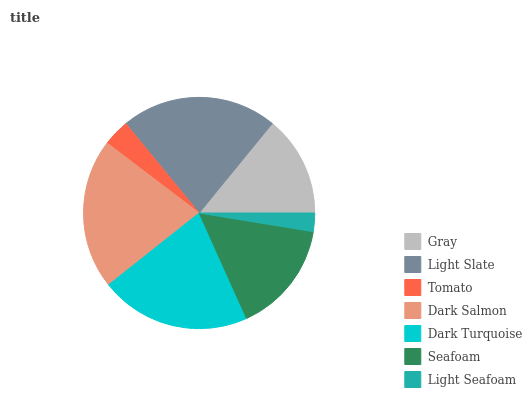Is Light Seafoam the minimum?
Answer yes or no. Yes. Is Light Slate the maximum?
Answer yes or no. Yes. Is Tomato the minimum?
Answer yes or no. No. Is Tomato the maximum?
Answer yes or no. No. Is Light Slate greater than Tomato?
Answer yes or no. Yes. Is Tomato less than Light Slate?
Answer yes or no. Yes. Is Tomato greater than Light Slate?
Answer yes or no. No. Is Light Slate less than Tomato?
Answer yes or no. No. Is Seafoam the high median?
Answer yes or no. Yes. Is Seafoam the low median?
Answer yes or no. Yes. Is Light Seafoam the high median?
Answer yes or no. No. Is Gray the low median?
Answer yes or no. No. 